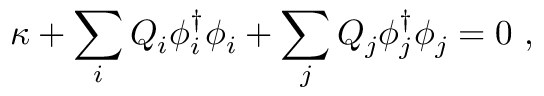<formula> <loc_0><loc_0><loc_500><loc_500>\kappa + \sum _ { i } Q _ { i } \phi _ { i } ^ { \dagger } \phi _ { i } + \sum _ { j } Q _ { j } \phi _ { j } ^ { \dagger } \phi _ { j } = 0 \ ,</formula> 